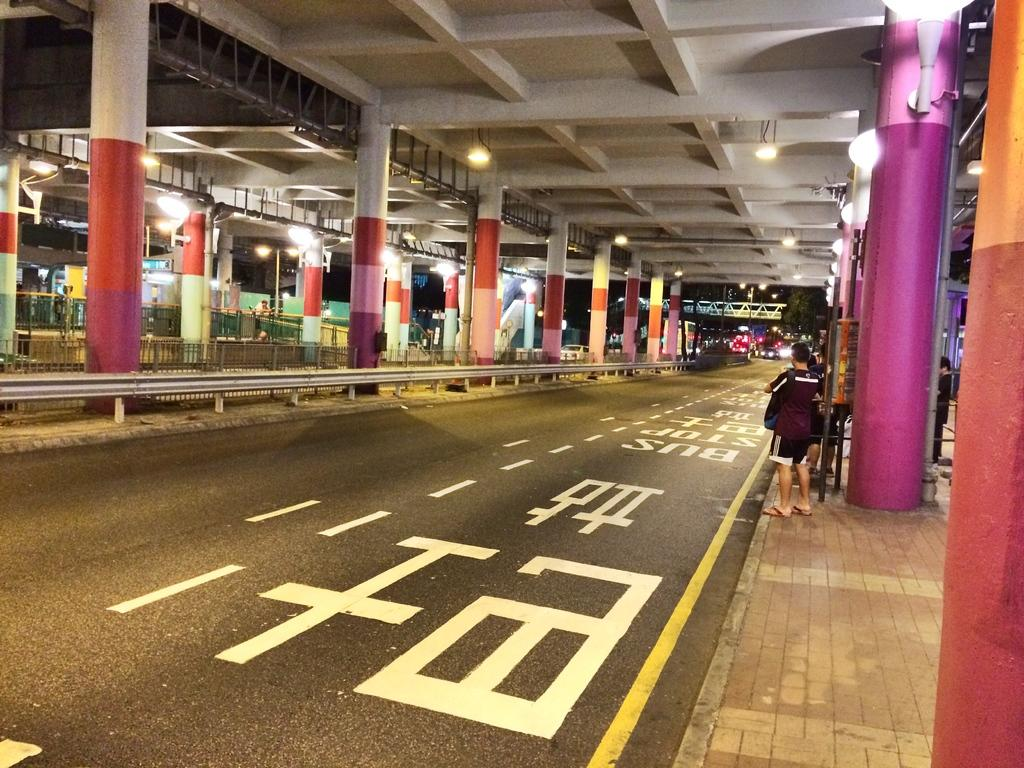How many persons are visible in the image? There are persons in the image, but the exact number is not specified. What type of infrastructure can be seen in the image? There is a road, pillars, lights, and poles visible in the image. What type of natural elements are present in the image? There are trees in the image. What type of brain can be seen in the image? There is no brain present in the image. Can you describe how the persons are jumping in the image? There is no indication that the persons are jumping in the image. 